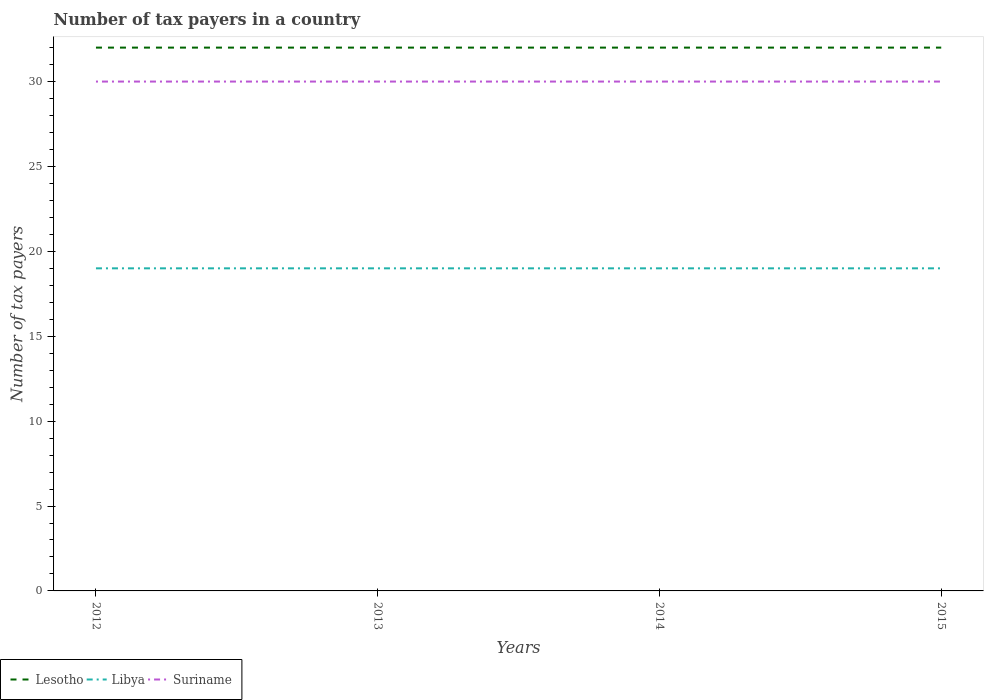How many different coloured lines are there?
Your answer should be compact. 3. Does the line corresponding to Libya intersect with the line corresponding to Lesotho?
Your response must be concise. No. Is the number of lines equal to the number of legend labels?
Keep it short and to the point. Yes. In which year was the number of tax payers in in Lesotho maximum?
Offer a terse response. 2012. What is the total number of tax payers in in Libya in the graph?
Provide a succinct answer. 0. What is the difference between the highest and the second highest number of tax payers in in Lesotho?
Provide a succinct answer. 0. How many years are there in the graph?
Ensure brevity in your answer.  4. Where does the legend appear in the graph?
Provide a short and direct response. Bottom left. What is the title of the graph?
Your response must be concise. Number of tax payers in a country. What is the label or title of the Y-axis?
Offer a very short reply. Number of tax payers. What is the Number of tax payers of Lesotho in 2012?
Keep it short and to the point. 32. What is the Number of tax payers of Lesotho in 2013?
Offer a terse response. 32. What is the Number of tax payers of Lesotho in 2014?
Your response must be concise. 32. What is the Number of tax payers of Lesotho in 2015?
Your response must be concise. 32. Across all years, what is the minimum Number of tax payers of Lesotho?
Your answer should be very brief. 32. What is the total Number of tax payers of Lesotho in the graph?
Offer a terse response. 128. What is the total Number of tax payers in Libya in the graph?
Your answer should be compact. 76. What is the total Number of tax payers of Suriname in the graph?
Ensure brevity in your answer.  120. What is the difference between the Number of tax payers of Lesotho in 2012 and that in 2013?
Your answer should be compact. 0. What is the difference between the Number of tax payers of Suriname in 2012 and that in 2013?
Keep it short and to the point. 0. What is the difference between the Number of tax payers in Libya in 2012 and that in 2014?
Offer a very short reply. 0. What is the difference between the Number of tax payers in Libya in 2012 and that in 2015?
Offer a very short reply. 0. What is the difference between the Number of tax payers of Lesotho in 2013 and that in 2014?
Provide a short and direct response. 0. What is the difference between the Number of tax payers in Libya in 2013 and that in 2015?
Your response must be concise. 0. What is the difference between the Number of tax payers in Libya in 2014 and that in 2015?
Your answer should be very brief. 0. What is the difference between the Number of tax payers in Lesotho in 2012 and the Number of tax payers in Libya in 2013?
Make the answer very short. 13. What is the difference between the Number of tax payers of Libya in 2012 and the Number of tax payers of Suriname in 2013?
Provide a succinct answer. -11. What is the difference between the Number of tax payers in Lesotho in 2012 and the Number of tax payers in Libya in 2015?
Provide a succinct answer. 13. What is the difference between the Number of tax payers of Lesotho in 2012 and the Number of tax payers of Suriname in 2015?
Offer a terse response. 2. What is the difference between the Number of tax payers of Lesotho in 2013 and the Number of tax payers of Libya in 2014?
Your answer should be compact. 13. What is the difference between the Number of tax payers in Lesotho in 2014 and the Number of tax payers in Libya in 2015?
Your response must be concise. 13. What is the average Number of tax payers in Libya per year?
Your answer should be very brief. 19. In the year 2012, what is the difference between the Number of tax payers in Lesotho and Number of tax payers in Suriname?
Offer a terse response. 2. In the year 2014, what is the difference between the Number of tax payers in Libya and Number of tax payers in Suriname?
Offer a very short reply. -11. In the year 2015, what is the difference between the Number of tax payers of Lesotho and Number of tax payers of Libya?
Keep it short and to the point. 13. In the year 2015, what is the difference between the Number of tax payers of Lesotho and Number of tax payers of Suriname?
Your response must be concise. 2. In the year 2015, what is the difference between the Number of tax payers of Libya and Number of tax payers of Suriname?
Your answer should be compact. -11. What is the ratio of the Number of tax payers of Lesotho in 2012 to that in 2013?
Offer a very short reply. 1. What is the ratio of the Number of tax payers of Suriname in 2012 to that in 2013?
Offer a very short reply. 1. What is the ratio of the Number of tax payers in Lesotho in 2012 to that in 2014?
Your response must be concise. 1. What is the ratio of the Number of tax payers of Suriname in 2012 to that in 2014?
Your answer should be very brief. 1. What is the ratio of the Number of tax payers in Suriname in 2012 to that in 2015?
Make the answer very short. 1. What is the ratio of the Number of tax payers of Lesotho in 2013 to that in 2014?
Offer a terse response. 1. What is the ratio of the Number of tax payers of Lesotho in 2013 to that in 2015?
Offer a very short reply. 1. What is the ratio of the Number of tax payers of Libya in 2013 to that in 2015?
Offer a very short reply. 1. What is the ratio of the Number of tax payers in Lesotho in 2014 to that in 2015?
Your answer should be compact. 1. What is the ratio of the Number of tax payers in Suriname in 2014 to that in 2015?
Offer a very short reply. 1. What is the difference between the highest and the second highest Number of tax payers of Libya?
Offer a terse response. 0. What is the difference between the highest and the second highest Number of tax payers of Suriname?
Provide a short and direct response. 0. What is the difference between the highest and the lowest Number of tax payers of Suriname?
Ensure brevity in your answer.  0. 